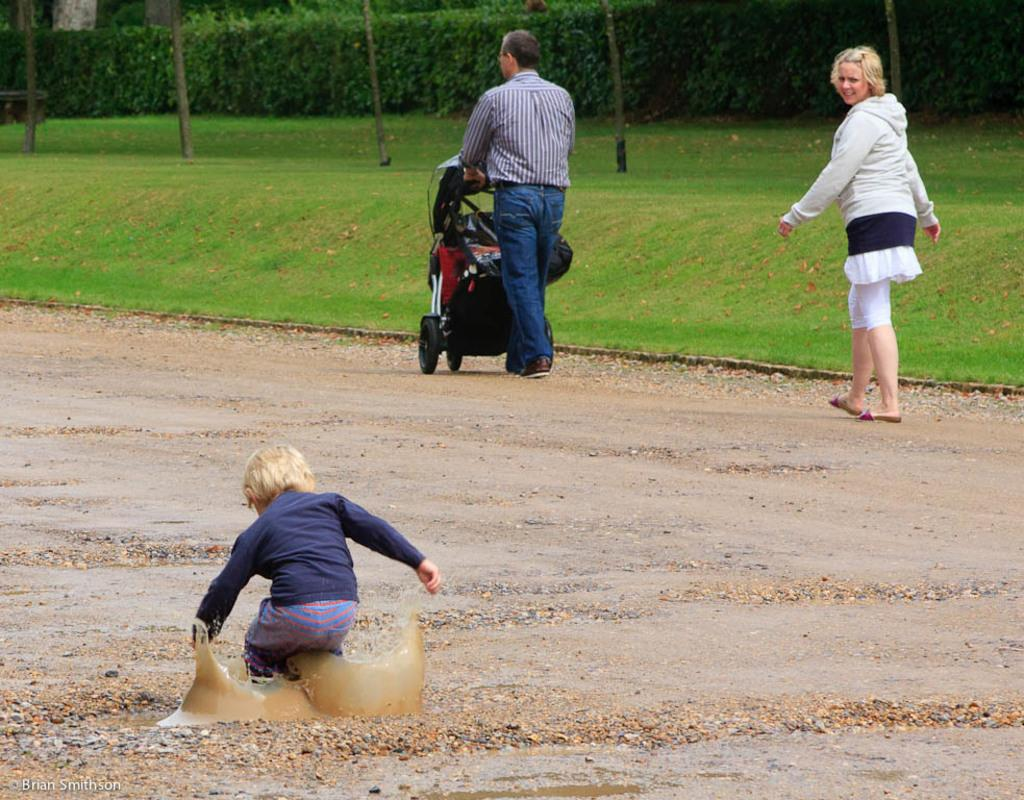What is happening on the road in the image? There are persons on the road in the image. What can be seen in the background of the image? There is grass, trees, and plants visible in the background of the image. What is the price of the shocking event happening in the image? There is no shocking event or price mentioned in the image; it simply shows persons on the road and vegetation in the background. 